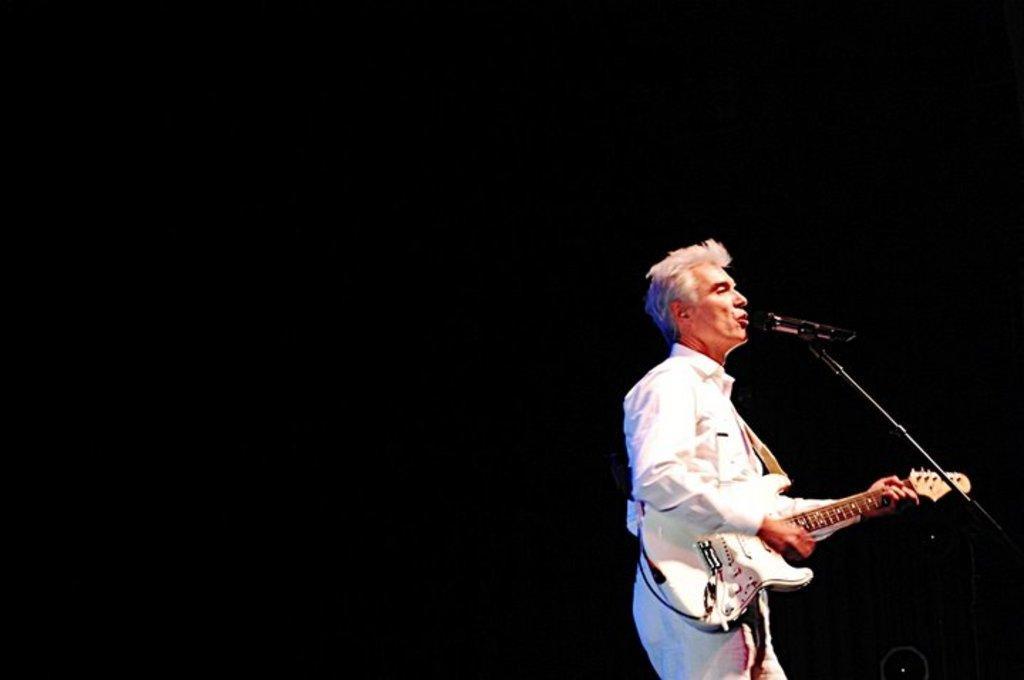In one or two sentences, can you explain what this image depicts? In this image I can see am an standing holding a guitar. There is a mic and a stand. 